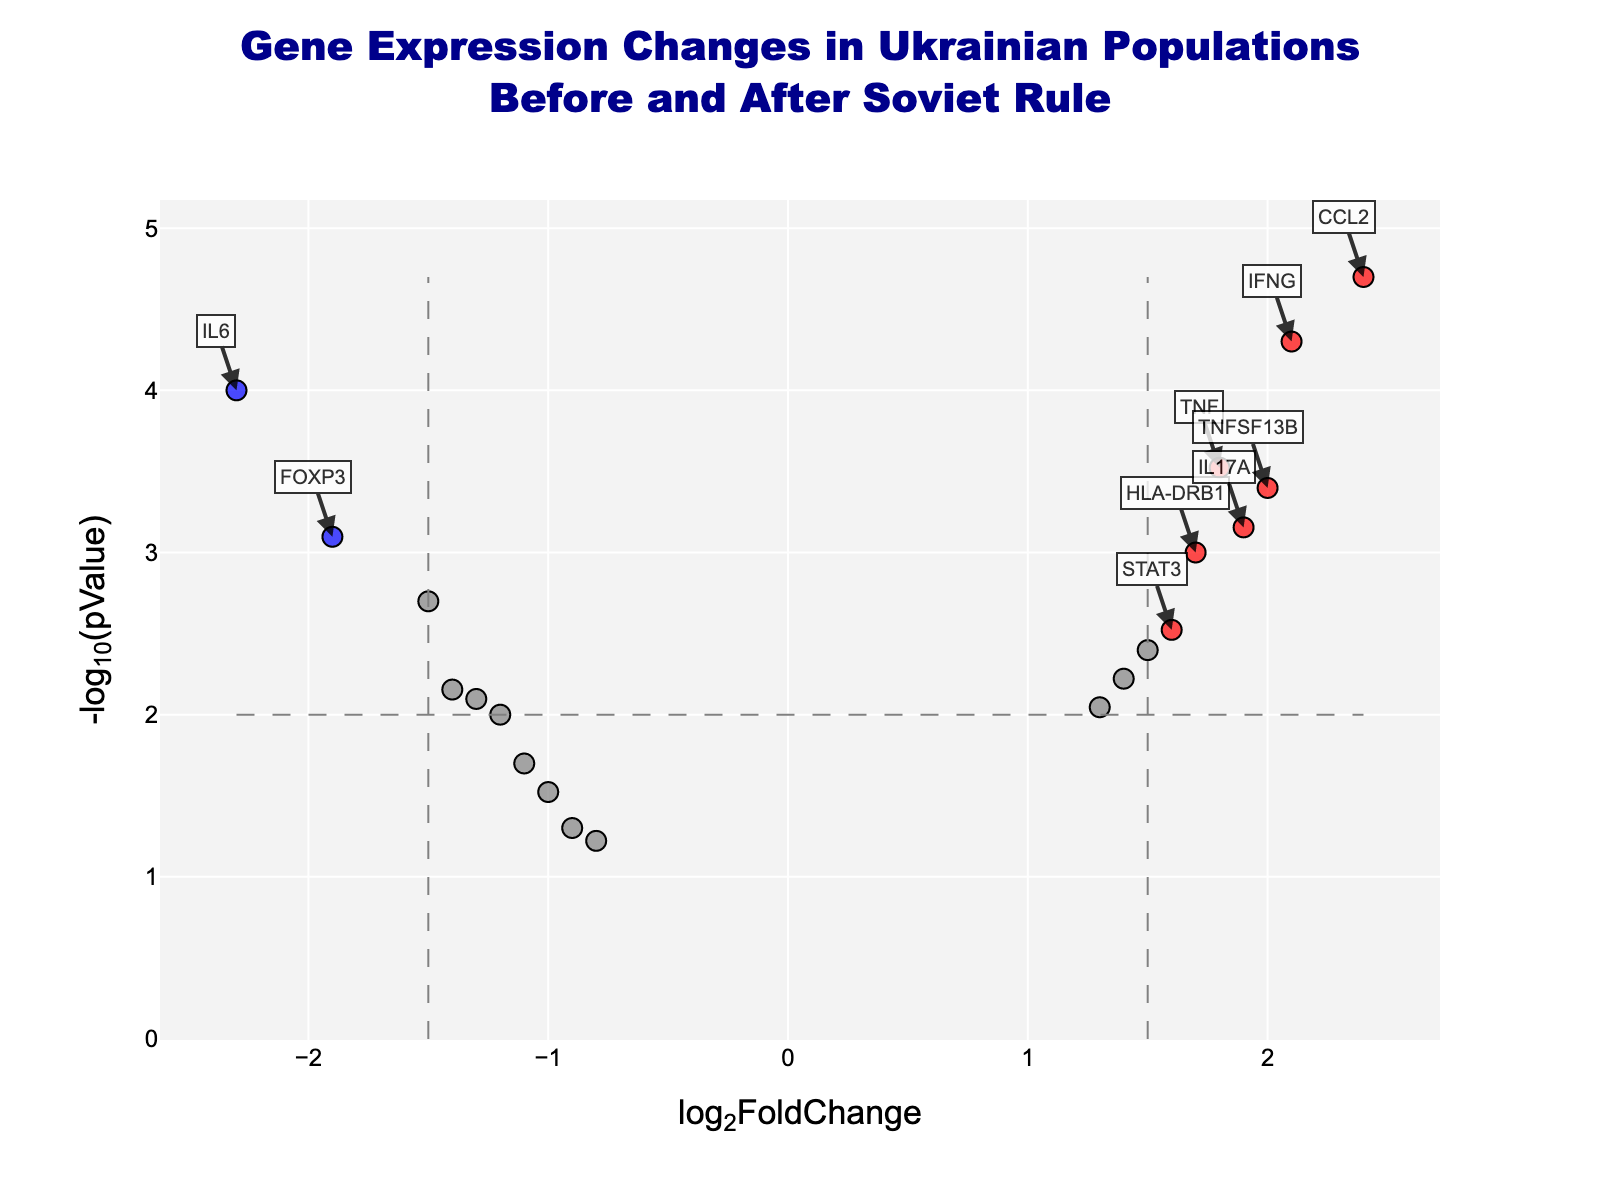What is the title of the figure? The title is usually found at the top of the figure. In this case, it reads "Gene Expression Changes in Ukrainian Populations Before and After Soviet Rule".
Answer: Gene Expression Changes in Ukrainian Populations Before and After Soviet Rule What are the axis labels? The x-axis label is "log2FoldChange" and the y-axis label is "-log10(pValue)", which can be found near the respective axes.
Answer: log2FoldChange and -log10(pValue) How many significant upregulated genes are there? Significant upregulated genes are typically marked in red and are located to the right of the vertical threshold line. Count the number of red points to get the answer.
Answer: 6 Which gene has the highest log2FoldChange value? Check the x-axis for the highest log2FoldChange value and identify the corresponding gene from the plot annotations.
Answer: CCL2 Which gene has the most significant p-value? The most significant p-value corresponds to the highest value on the y-axis. Check the plot annotation or hover text near the top of the plot.
Answer: CCL2 Which downregulated gene has the lowest log2FoldChange value? Look for blue points on the left side of the plot. The lowest log2FoldChange would be the farthest to the left.
Answer: IL6 What is the significance threshold for p-values represented in the plot? The threshold is shown by a horizontal dashed line, which represents the p-value cutoff, often at -log10(0.01).
Answer: 0.01 How many genes are neither significantly upregulated nor downregulated? Genes that are neither upregulated nor downregulated are colored grey. Count the number of grey points in the plot.
Answer: 9 Compare the log2FoldChange of TNFSF13B and IL17A. Which one is higher? Look at the x-axis positions of the points labeled TNFSF13B and IL17A and compare their log2FoldChange values.
Answer: IL17A Which gene has the lowest -log10(pValue) but is still significant? Significant genes have -log10(pValue) above the threshold line. Identify the point with the lowest position above the threshold among the significant points.
Answer: HLA-DRB1 